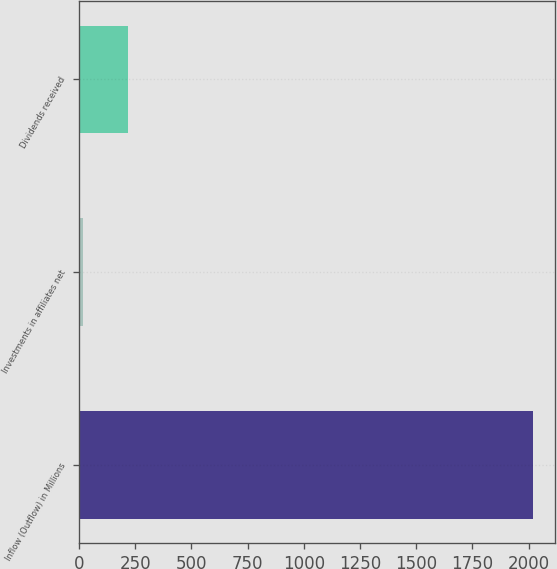Convert chart to OTSL. <chart><loc_0><loc_0><loc_500><loc_500><bar_chart><fcel>Inflow (Outflow) in Millions<fcel>Investments in affiliates net<fcel>Dividends received<nl><fcel>2018<fcel>17.3<fcel>217.37<nl></chart> 